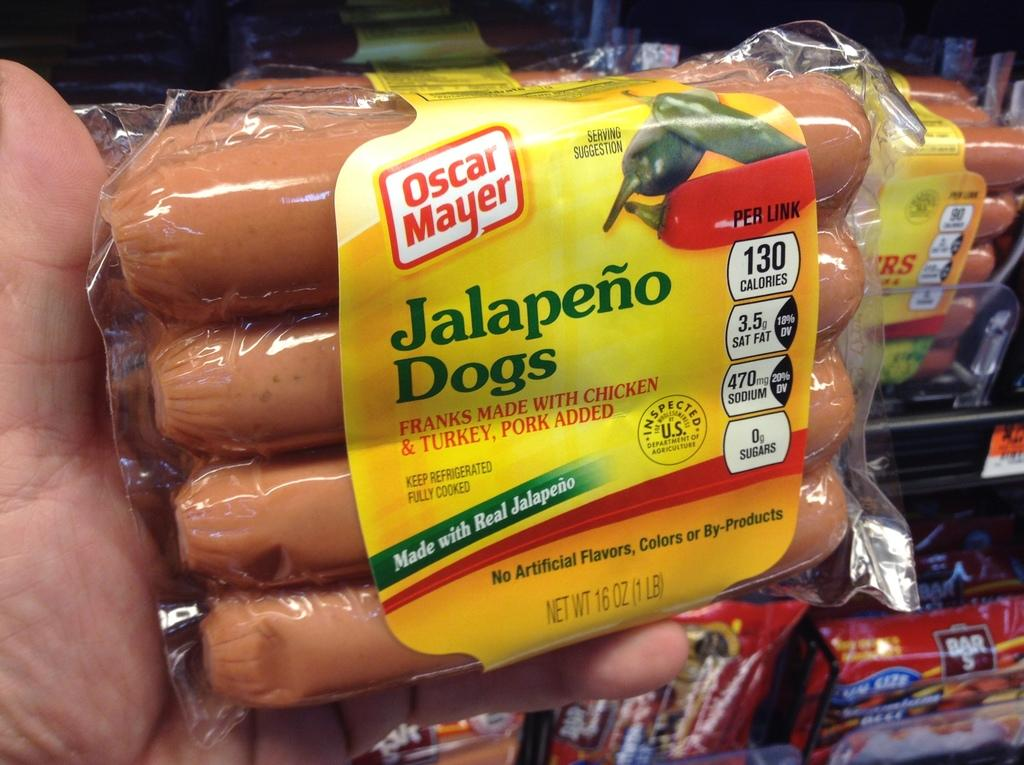What is present in the image? There is a person in the image. What is the person doing in the image? The person's hand is holding an object. What can be seen in the background of the image? There is a rack in the background of the image. What is on the rack? There are covers on the rack. What type of chain is being used by the person in the image? There is no chain present in the image. What is the person digging with in the image? There is no digging tool, such as a spade, present in the image. 